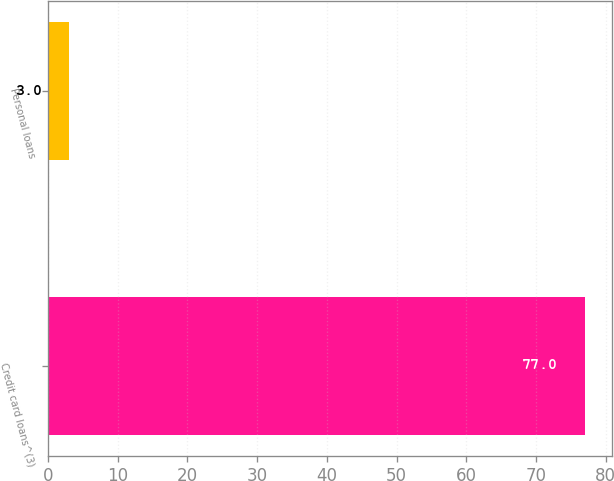<chart> <loc_0><loc_0><loc_500><loc_500><bar_chart><fcel>Credit card loans^(3)<fcel>Personal loans<nl><fcel>77<fcel>3<nl></chart> 